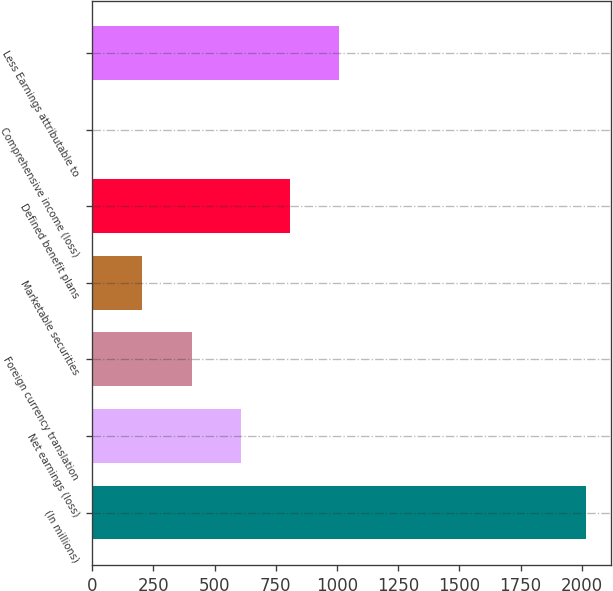Convert chart. <chart><loc_0><loc_0><loc_500><loc_500><bar_chart><fcel>(In millions)<fcel>Net earnings (loss)<fcel>Foreign currency translation<fcel>Marketable securities<fcel>Defined benefit plans<fcel>Comprehensive income (loss)<fcel>Less Earnings attributable to<nl><fcel>2017<fcel>607.9<fcel>406.6<fcel>205.3<fcel>809.2<fcel>4<fcel>1010.5<nl></chart> 